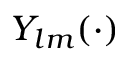Convert formula to latex. <formula><loc_0><loc_0><loc_500><loc_500>Y _ { l m } ( \cdot )</formula> 